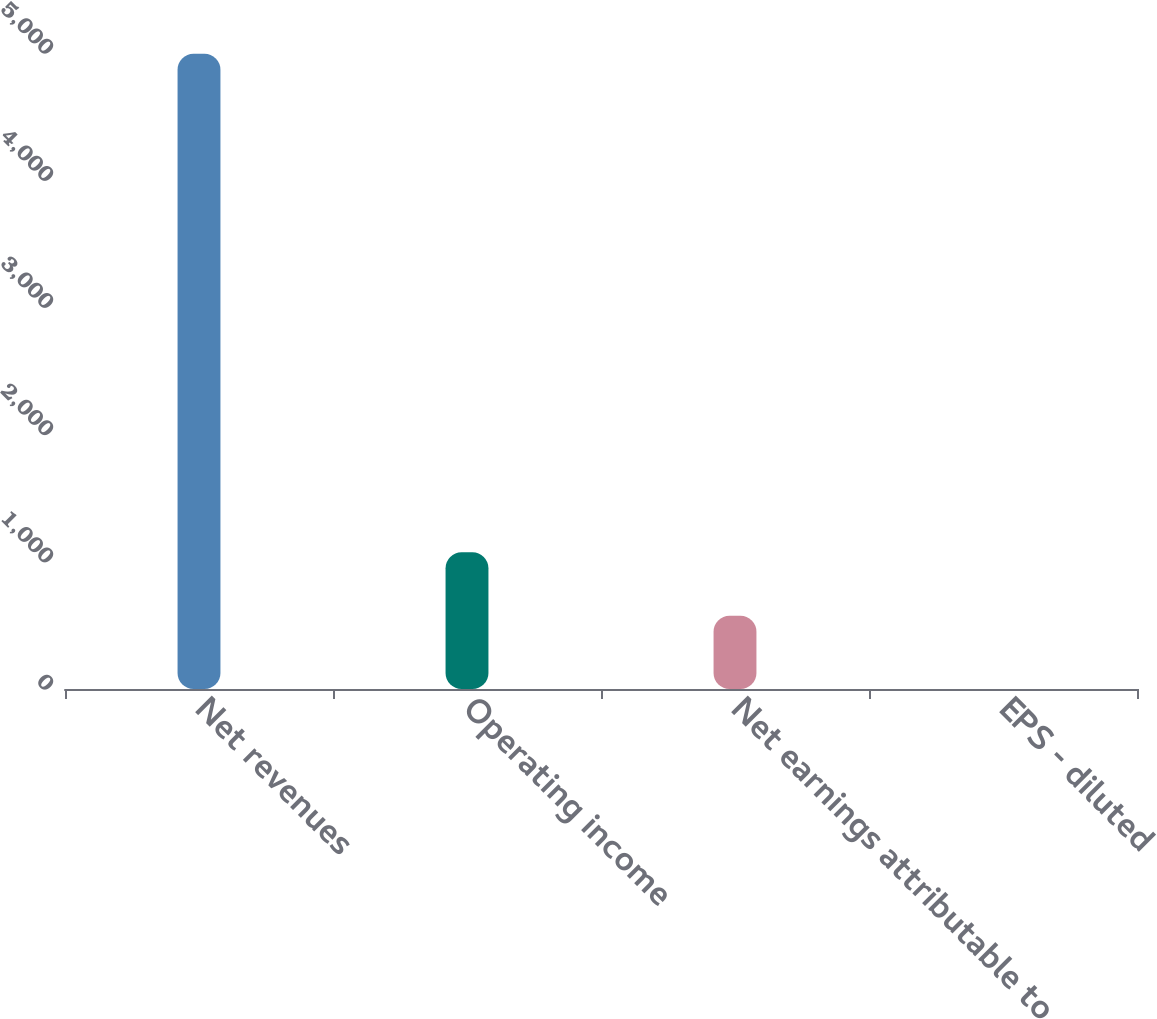Convert chart. <chart><loc_0><loc_0><loc_500><loc_500><bar_chart><fcel>Net revenues<fcel>Operating income<fcel>Net earnings attributable to<fcel>EPS - diluted<nl><fcel>4993.2<fcel>1074.38<fcel>575.1<fcel>0.39<nl></chart> 